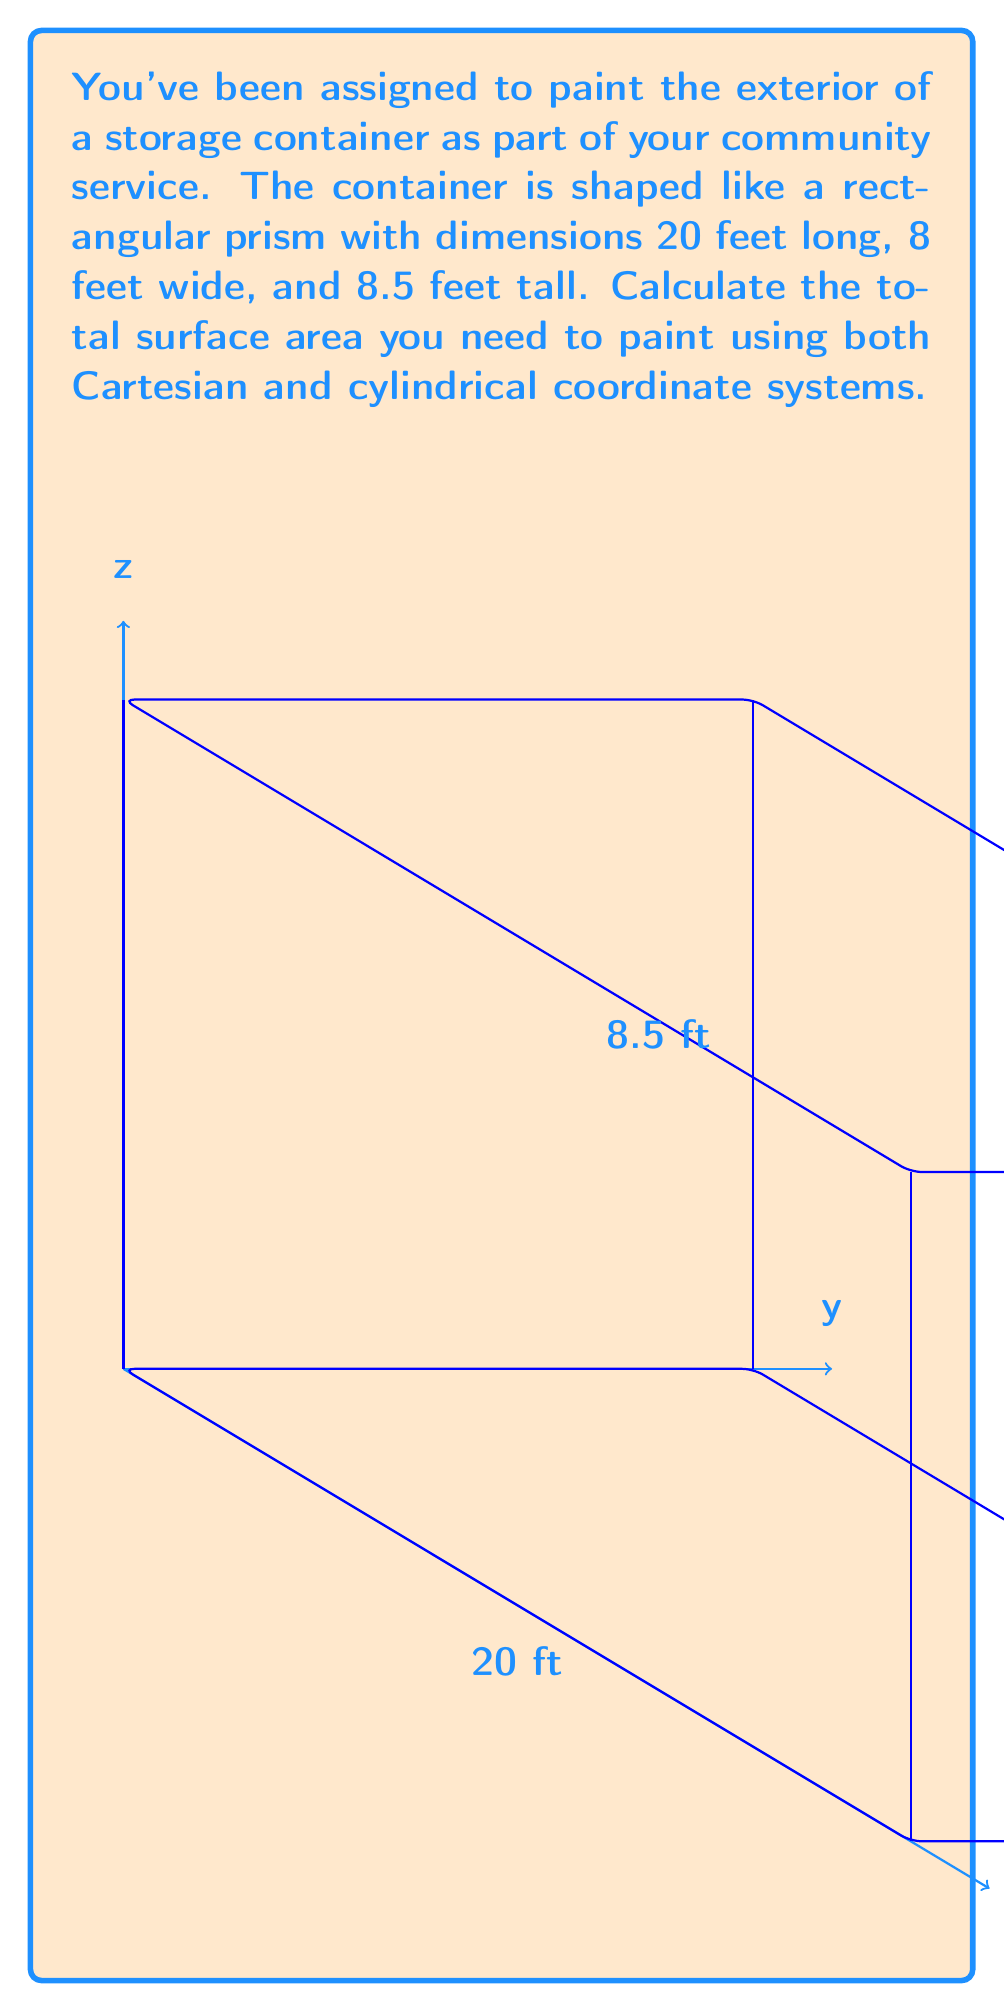Give your solution to this math problem. Let's approach this problem step-by-step using both coordinate systems:

1. Cartesian Coordinate System:
   In this system, we can easily calculate the area of each face and sum them up.
   
   a) Front and back faces: $A_1 = 2 \cdot (8 \cdot 8.5) = 136$ sq ft
   b) Left and right faces: $A_2 = 2 \cdot (20 \cdot 8.5) = 340$ sq ft
   c) Top and bottom faces: $A_3 = 2 \cdot (20 \cdot 8) = 320$ sq ft
   
   Total surface area: $A_{total} = A_1 + A_2 + A_3 = 136 + 340 + 320 = 796$ sq ft

2. Cylindrical Coordinate System:
   We can treat the container as a cylinder with a rectangular cross-section.
   Let's use $(r, \theta, z)$ coordinates where $z$ is along the length of the container.
   
   a) Side surfaces:
      $$A_{side} = \int_0^{20} \int_0^{2\pi} r(\theta) \, d\theta \, dz$$
      where $r(\theta) = 4/\cos\theta$ for $0 \leq \theta < \tan^{-1}(2)$ and $\pi - \tan^{-1}(2) < \theta \leq \pi$,
      and $r(\theta) = 4/\sin\theta$ for $\tan^{-1}(2) \leq \theta \leq \pi - \tan^{-1}(2)$.
      
      This simplifies to: $A_{side} = 20 \cdot (2 \cdot 8 + 2 \cdot 8.5) = 660$ sq ft
   
   b) End caps:
      $$A_{end} = 2 \cdot \int_0^4 \int_0^{8.5} r \, dz \, dr = 2 \cdot (4 \cdot 8.5) = 136$$ sq ft
   
   Total surface area: $A_{total} = A_{side} + A_{end} = 660 + 136 = 796$ sq ft

Both methods yield the same result, confirming our calculation.
Answer: 796 sq ft 